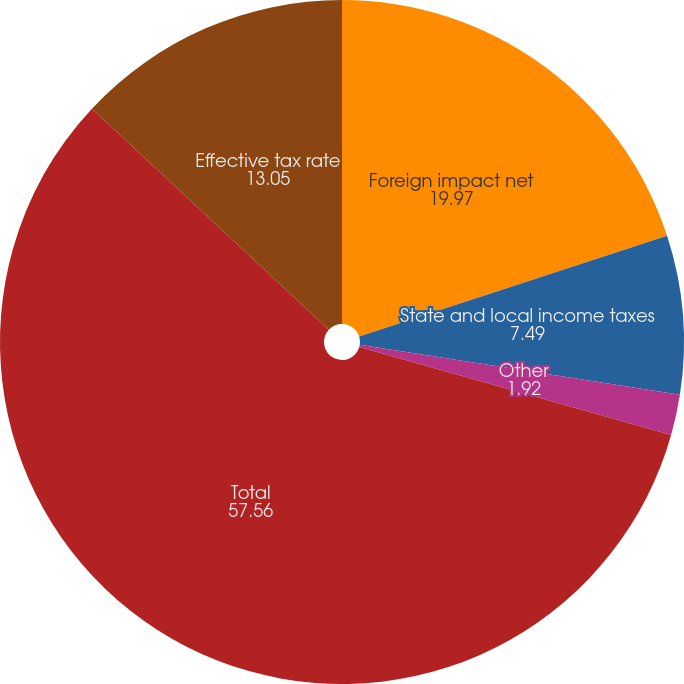Convert chart to OTSL. <chart><loc_0><loc_0><loc_500><loc_500><pie_chart><fcel>Foreign impact net<fcel>State and local income taxes<fcel>Other<fcel>Total<fcel>Effective tax rate<nl><fcel>19.97%<fcel>7.49%<fcel>1.92%<fcel>57.56%<fcel>13.05%<nl></chart> 